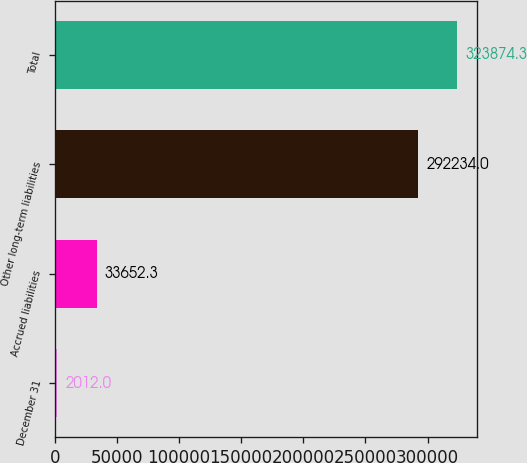Convert chart to OTSL. <chart><loc_0><loc_0><loc_500><loc_500><bar_chart><fcel>December 31<fcel>Accrued liabilities<fcel>Other long-term liabilities<fcel>Total<nl><fcel>2012<fcel>33652.3<fcel>292234<fcel>323874<nl></chart> 